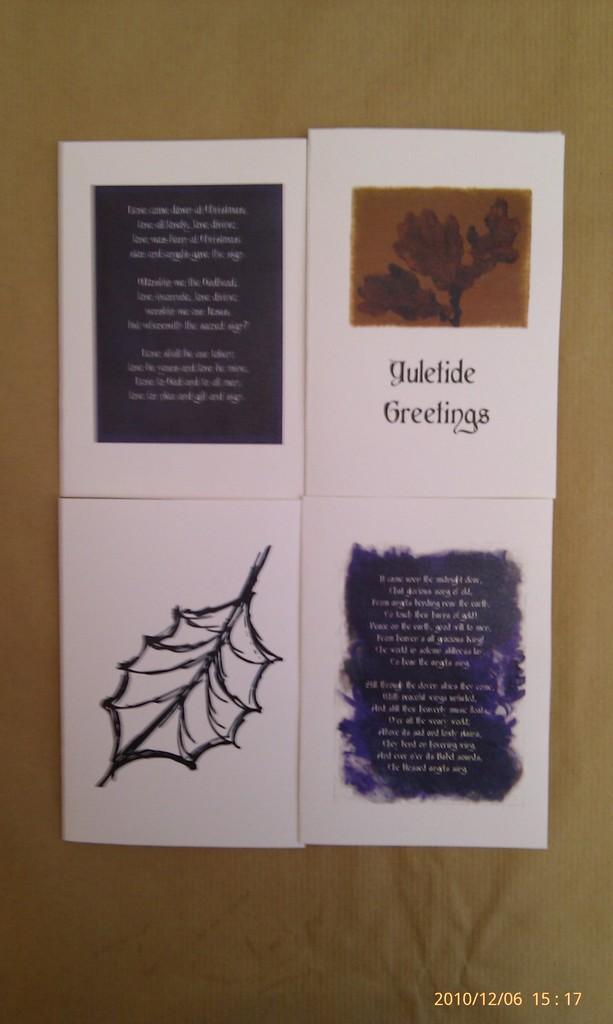Please provide a concise description of this image. In the foreground of this image, there are four papers pasted on a brown surface. 